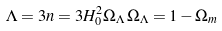<formula> <loc_0><loc_0><loc_500><loc_500>\Lambda = 3 n = 3 H ^ { 2 } _ { 0 } \Omega _ { \Lambda } \, \Omega _ { \Lambda } = 1 - \Omega _ { m }</formula> 